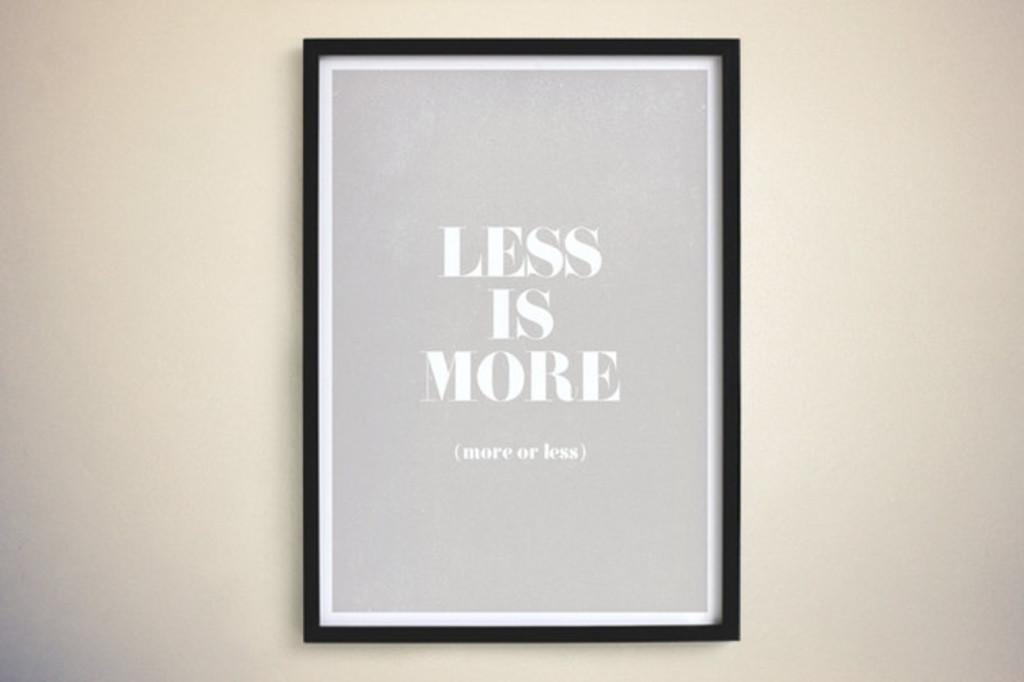<image>
Render a clear and concise summary of the photo. a frame with less is more or more or less written 